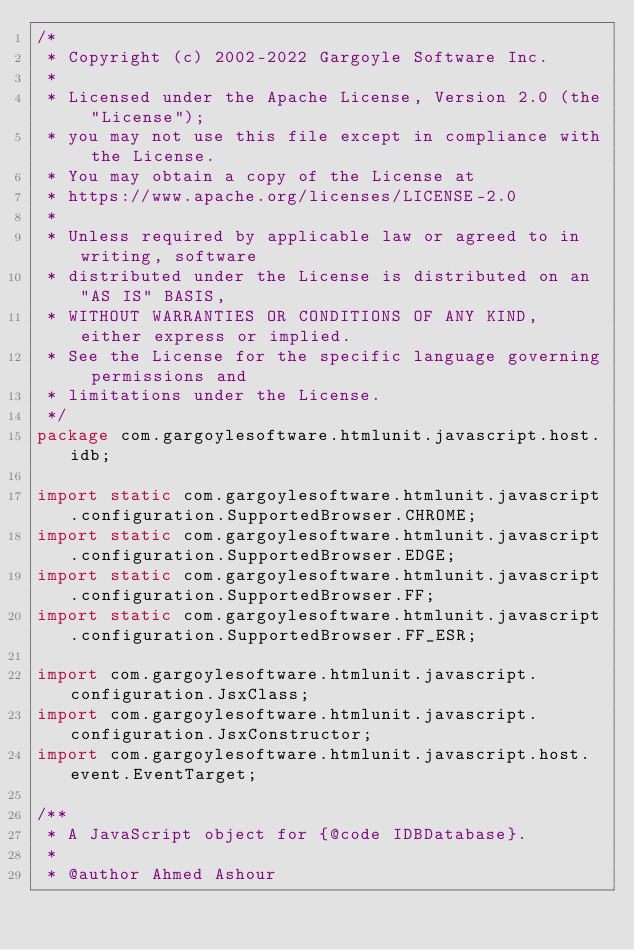<code> <loc_0><loc_0><loc_500><loc_500><_Java_>/*
 * Copyright (c) 2002-2022 Gargoyle Software Inc.
 *
 * Licensed under the Apache License, Version 2.0 (the "License");
 * you may not use this file except in compliance with the License.
 * You may obtain a copy of the License at
 * https://www.apache.org/licenses/LICENSE-2.0
 *
 * Unless required by applicable law or agreed to in writing, software
 * distributed under the License is distributed on an "AS IS" BASIS,
 * WITHOUT WARRANTIES OR CONDITIONS OF ANY KIND, either express or implied.
 * See the License for the specific language governing permissions and
 * limitations under the License.
 */
package com.gargoylesoftware.htmlunit.javascript.host.idb;

import static com.gargoylesoftware.htmlunit.javascript.configuration.SupportedBrowser.CHROME;
import static com.gargoylesoftware.htmlunit.javascript.configuration.SupportedBrowser.EDGE;
import static com.gargoylesoftware.htmlunit.javascript.configuration.SupportedBrowser.FF;
import static com.gargoylesoftware.htmlunit.javascript.configuration.SupportedBrowser.FF_ESR;

import com.gargoylesoftware.htmlunit.javascript.configuration.JsxClass;
import com.gargoylesoftware.htmlunit.javascript.configuration.JsxConstructor;
import com.gargoylesoftware.htmlunit.javascript.host.event.EventTarget;

/**
 * A JavaScript object for {@code IDBDatabase}.
 *
 * @author Ahmed Ashour</code> 